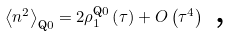<formula> <loc_0><loc_0><loc_500><loc_500>\left \langle n ^ { 2 } \right \rangle _ { \text {Q} 0 } = 2 \rho _ { 1 } ^ { \text {Q} 0 } \left ( \tau \right ) + O \left ( \tau ^ { 4 } \right ) \text { ,}</formula> 